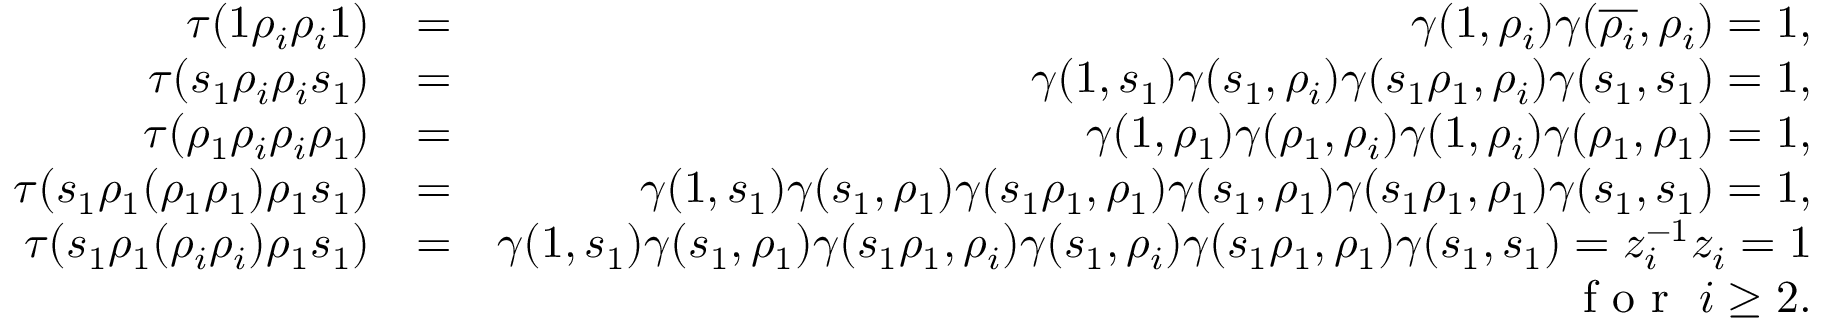Convert formula to latex. <formula><loc_0><loc_0><loc_500><loc_500>\begin{array} { r l r } { \tau ( 1 \rho _ { i } \rho _ { i } 1 ) } & { = } & { \gamma ( 1 , \rho _ { i } ) \gamma ( \overline { { \rho _ { i } } } , \rho _ { i } ) = 1 , } \\ { \tau ( s _ { 1 } \rho _ { i } \rho _ { i } s _ { 1 } ) } & { = } & { \gamma ( 1 , s _ { 1 } ) \gamma ( s _ { 1 } , \rho _ { i } ) \gamma ( s _ { 1 } \rho _ { 1 } , \rho _ { i } ) \gamma ( s _ { 1 } , s _ { 1 } ) = 1 , } \\ { \tau ( \rho _ { 1 } \rho _ { i } \rho _ { i } \rho _ { 1 } ) } & { = } & { \gamma ( 1 , \rho _ { 1 } ) \gamma ( \rho _ { 1 } , \rho _ { i } ) \gamma ( 1 , \rho _ { i } ) \gamma ( \rho _ { 1 } , \rho _ { 1 } ) = 1 , } \\ { \tau ( s _ { 1 } \rho _ { 1 } ( \rho _ { 1 } \rho _ { 1 } ) \rho _ { 1 } s _ { 1 } ) } & { = } & { \gamma ( 1 , s _ { 1 } ) \gamma ( s _ { 1 } , \rho _ { 1 } ) \gamma ( s _ { 1 } \rho _ { 1 } , \rho _ { 1 } ) \gamma ( s _ { 1 } , \rho _ { 1 } ) \gamma ( s _ { 1 } \rho _ { 1 } , \rho _ { 1 } ) \gamma ( s _ { 1 } , s _ { 1 } ) = 1 , } \\ { \tau ( s _ { 1 } \rho _ { 1 } ( \rho _ { i } \rho _ { i } ) \rho _ { 1 } s _ { 1 } ) } & { = } & { \gamma ( 1 , s _ { 1 } ) \gamma ( s _ { 1 } , \rho _ { 1 } ) \gamma ( s _ { 1 } \rho _ { 1 } , \rho _ { i } ) \gamma ( s _ { 1 } , \rho _ { i } ) \gamma ( s _ { 1 } \rho _ { 1 } , \rho _ { 1 } ) \gamma ( s _ { 1 } , s _ { 1 } ) = z _ { i } ^ { - 1 } z _ { i } = 1 } \\ & { f o r i \geq 2 . } \end{array}</formula> 